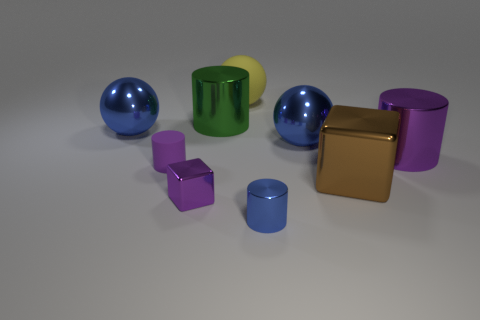How many purple cylinders must be subtracted to get 1 purple cylinders? 1 Subtract 0 brown cylinders. How many objects are left? 9 Subtract all cylinders. How many objects are left? 5 Subtract 3 cylinders. How many cylinders are left? 1 Subtract all red cylinders. Subtract all red balls. How many cylinders are left? 4 Subtract all green spheres. How many brown cubes are left? 1 Subtract all purple things. Subtract all green objects. How many objects are left? 5 Add 2 cubes. How many cubes are left? 4 Add 8 large green balls. How many large green balls exist? 8 Add 1 large purple metal cylinders. How many objects exist? 10 